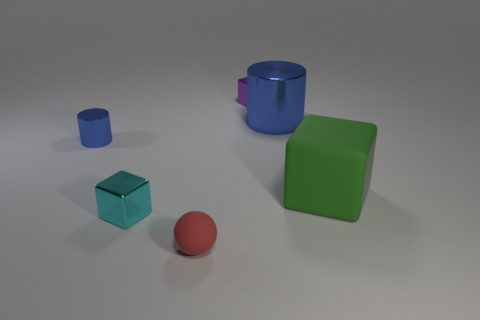Subtract all matte blocks. How many blocks are left? 2 Add 4 large green rubber things. How many objects exist? 10 Subtract all green cubes. How many cubes are left? 2 Add 6 cyan shiny objects. How many cyan shiny objects exist? 7 Subtract 0 yellow cubes. How many objects are left? 6 Subtract all spheres. How many objects are left? 5 Subtract 1 cylinders. How many cylinders are left? 1 Subtract all yellow cubes. Subtract all brown cylinders. How many cubes are left? 3 Subtract all gray cylinders. How many green cubes are left? 1 Subtract all blue things. Subtract all metallic blocks. How many objects are left? 2 